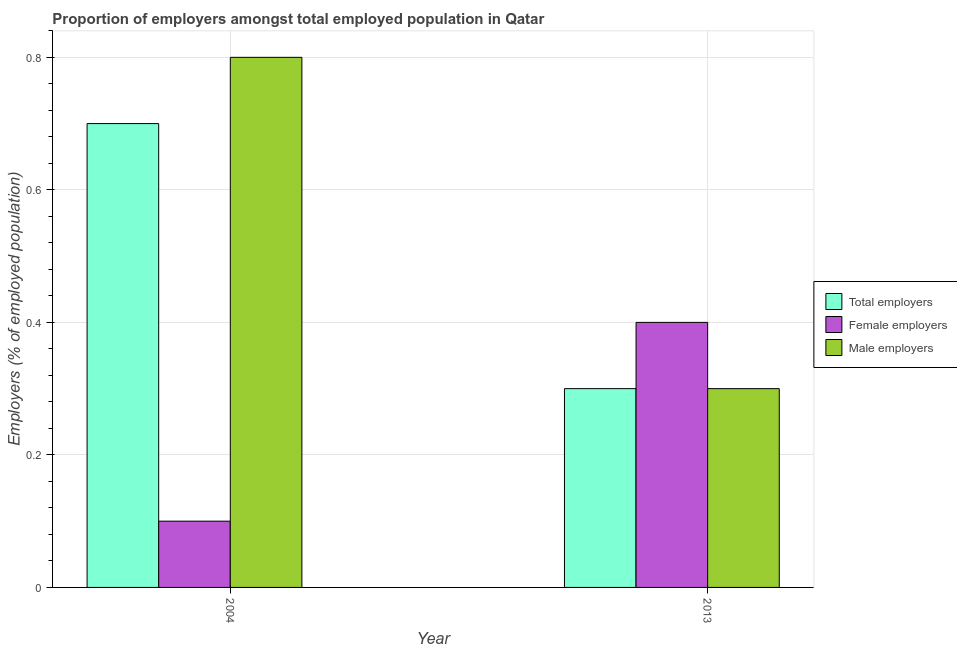How many groups of bars are there?
Offer a terse response. 2. Are the number of bars on each tick of the X-axis equal?
Give a very brief answer. Yes. How many bars are there on the 2nd tick from the left?
Offer a very short reply. 3. What is the label of the 1st group of bars from the left?
Provide a short and direct response. 2004. In how many cases, is the number of bars for a given year not equal to the number of legend labels?
Offer a very short reply. 0. What is the percentage of female employers in 2004?
Keep it short and to the point. 0.1. Across all years, what is the maximum percentage of total employers?
Provide a succinct answer. 0.7. Across all years, what is the minimum percentage of male employers?
Provide a short and direct response. 0.3. In which year was the percentage of female employers maximum?
Your answer should be very brief. 2013. What is the total percentage of male employers in the graph?
Provide a succinct answer. 1.1. What is the difference between the percentage of female employers in 2004 and that in 2013?
Provide a short and direct response. -0.3. What is the difference between the percentage of male employers in 2013 and the percentage of female employers in 2004?
Keep it short and to the point. -0.5. What is the average percentage of female employers per year?
Provide a short and direct response. 0.25. In the year 2013, what is the difference between the percentage of total employers and percentage of male employers?
Your response must be concise. 0. In how many years, is the percentage of male employers greater than 0.32 %?
Keep it short and to the point. 1. What does the 3rd bar from the left in 2013 represents?
Keep it short and to the point. Male employers. What does the 2nd bar from the right in 2004 represents?
Provide a succinct answer. Female employers. Is it the case that in every year, the sum of the percentage of total employers and percentage of female employers is greater than the percentage of male employers?
Your response must be concise. No. How many bars are there?
Ensure brevity in your answer.  6. Are the values on the major ticks of Y-axis written in scientific E-notation?
Keep it short and to the point. No. Does the graph contain any zero values?
Your answer should be very brief. No. Does the graph contain grids?
Your response must be concise. Yes. How are the legend labels stacked?
Keep it short and to the point. Vertical. What is the title of the graph?
Your answer should be very brief. Proportion of employers amongst total employed population in Qatar. Does "Poland" appear as one of the legend labels in the graph?
Provide a succinct answer. No. What is the label or title of the Y-axis?
Provide a succinct answer. Employers (% of employed population). What is the Employers (% of employed population) in Total employers in 2004?
Provide a short and direct response. 0.7. What is the Employers (% of employed population) of Female employers in 2004?
Keep it short and to the point. 0.1. What is the Employers (% of employed population) in Male employers in 2004?
Provide a short and direct response. 0.8. What is the Employers (% of employed population) of Total employers in 2013?
Your answer should be compact. 0.3. What is the Employers (% of employed population) in Female employers in 2013?
Make the answer very short. 0.4. What is the Employers (% of employed population) of Male employers in 2013?
Ensure brevity in your answer.  0.3. Across all years, what is the maximum Employers (% of employed population) in Total employers?
Make the answer very short. 0.7. Across all years, what is the maximum Employers (% of employed population) in Female employers?
Give a very brief answer. 0.4. Across all years, what is the maximum Employers (% of employed population) of Male employers?
Offer a very short reply. 0.8. Across all years, what is the minimum Employers (% of employed population) in Total employers?
Give a very brief answer. 0.3. Across all years, what is the minimum Employers (% of employed population) in Female employers?
Your answer should be very brief. 0.1. Across all years, what is the minimum Employers (% of employed population) of Male employers?
Give a very brief answer. 0.3. What is the total Employers (% of employed population) in Female employers in the graph?
Offer a very short reply. 0.5. What is the total Employers (% of employed population) in Male employers in the graph?
Your answer should be compact. 1.1. What is the difference between the Employers (% of employed population) in Total employers in 2004 and that in 2013?
Provide a short and direct response. 0.4. What is the difference between the Employers (% of employed population) in Female employers in 2004 and that in 2013?
Give a very brief answer. -0.3. What is the average Employers (% of employed population) in Total employers per year?
Your response must be concise. 0.5. What is the average Employers (% of employed population) in Female employers per year?
Give a very brief answer. 0.25. What is the average Employers (% of employed population) of Male employers per year?
Give a very brief answer. 0.55. In the year 2013, what is the difference between the Employers (% of employed population) in Total employers and Employers (% of employed population) in Male employers?
Your answer should be compact. 0. What is the ratio of the Employers (% of employed population) of Total employers in 2004 to that in 2013?
Your answer should be compact. 2.33. What is the ratio of the Employers (% of employed population) in Female employers in 2004 to that in 2013?
Provide a succinct answer. 0.25. What is the ratio of the Employers (% of employed population) in Male employers in 2004 to that in 2013?
Keep it short and to the point. 2.67. What is the difference between the highest and the second highest Employers (% of employed population) of Total employers?
Your answer should be very brief. 0.4. What is the difference between the highest and the second highest Employers (% of employed population) of Female employers?
Offer a terse response. 0.3. What is the difference between the highest and the second highest Employers (% of employed population) in Male employers?
Offer a terse response. 0.5. What is the difference between the highest and the lowest Employers (% of employed population) in Total employers?
Ensure brevity in your answer.  0.4. What is the difference between the highest and the lowest Employers (% of employed population) of Female employers?
Offer a very short reply. 0.3. What is the difference between the highest and the lowest Employers (% of employed population) of Male employers?
Make the answer very short. 0.5. 